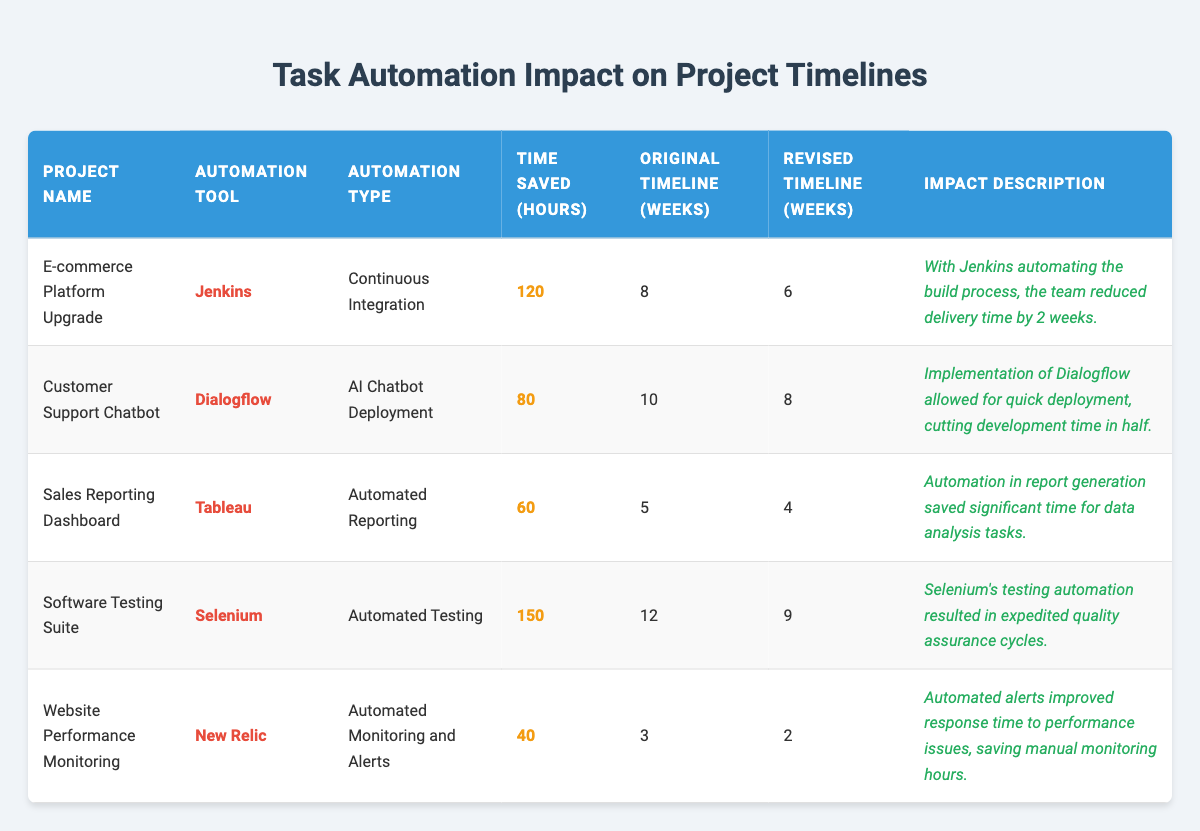What project saved the most time through automation? The project "Software Testing Suite" saved 150 hours, which is more than any other project listed.
Answer: Software Testing Suite Which automation tool was used for the E-commerce Platform Upgrade? The E-commerce Platform Upgrade utilized Jenkins as its automation tool.
Answer: Jenkins What was the original timeline for the Sales Reporting Dashboard? The original timeline for the Sales Reporting Dashboard was 5 weeks.
Answer: 5 weeks How much time was saved on the Customer Support Chatbot project? The Customer Support Chatbot project saved 80 hours of development time by implementing Dialogflow.
Answer: 80 hours Is it true that the Website Performance Monitoring project had a revised timeline shorter than its original? Yes, the original timeline was 3 weeks, and it was revised to 2 weeks, indicating a shorter timeline.
Answer: Yes Calculate the total time saved across all projects. The time saved for each project is added as follows: 120 + 80 + 60 + 150 + 40 = 450 hours in total.
Answer: 450 hours What was the impact description for the Sales Reporting Dashboard? The impact description states that automation in report generation saved significant time for data analysis tasks.
Answer: Automation in report generation saved significant time for data analysis tasks Which project had the least time saved due to automation? The project "Website Performance Monitoring" had the least time saved at 40 hours.
Answer: Website Performance Monitoring What is the average time saved across all projects? The total time saved is 450 hours across 5 projects, so the average is calculated as 450/5 = 90 hours.
Answer: 90 hours Which project shows a reduction in timeline of more than 3 weeks? The "Software Testing Suite" shows a reduction of 3 weeks (from 12 to 9 weeks), which is the only project with such a significant change.
Answer: Software Testing Suite 